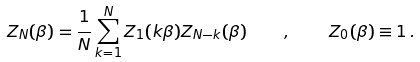<formula> <loc_0><loc_0><loc_500><loc_500>Z _ { N } ( \beta ) = \frac { 1 } { N } \sum _ { k = 1 } ^ { N } Z _ { 1 } ( k \beta ) Z _ { N - k } ( \beta ) \quad , \quad Z _ { 0 } ( \beta ) \equiv 1 \, .</formula> 